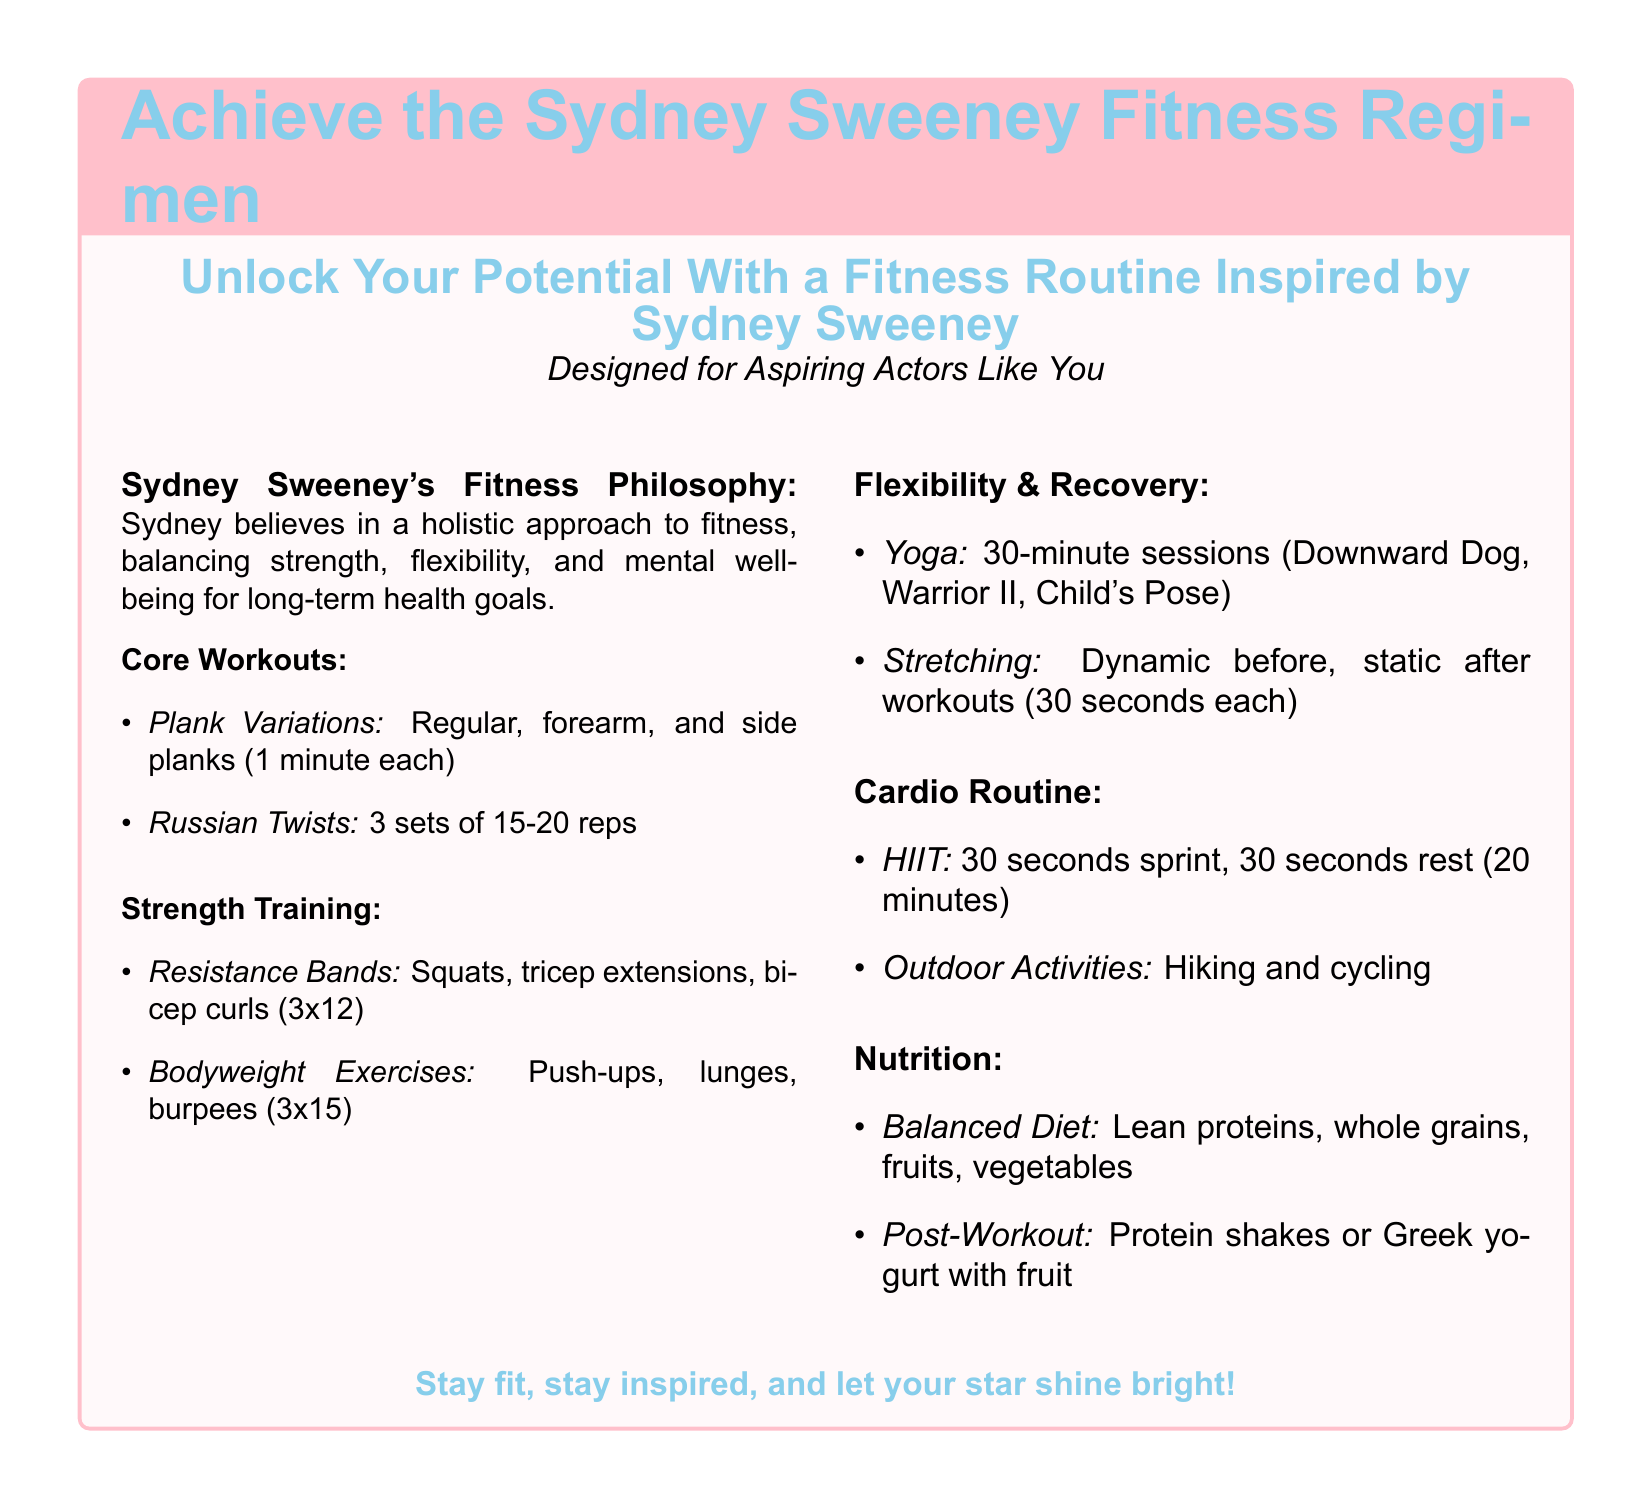What is Sydney Sweeney's fitness philosophy? The document states that Sydney believes in a holistic approach to fitness, balancing strength, flexibility, and mental well-being for long-term health goals.
Answer: holistic approach How long are the yoga sessions that Sydney includes in her fitness regimen? According to the document, the yoga sessions last for 30 minutes.
Answer: 30 minutes What type of exercises does Sydney include for core workouts? The document lists plank variations and Russian twists as her core workouts.
Answer: plank variations and Russian twists How many sets of Russian twists does Sydney perform? The document indicates that she performs 3 sets of 15-20 reps of Russian twists.
Answer: 3 sets of 15-20 reps What is included in Sydney's post-workout nutrition? The document mentions that her post-workout nutrition includes protein shakes or Greek yogurt with fruit.
Answer: protein shakes or Greek yogurt with fruit What is the first exercise listed under strength training? The document lists resistance bands squats as the first exercise under strength training.
Answer: resistance bands squats How long does Sydney's HIIT cardio routine last? The document states that the HIIT cardio routine lasts for 20 minutes.
Answer: 20 minutes What type of diet does Sydney follow according to the document? The document describes her diet as balanced, which includes lean proteins, whole grains, fruits, and vegetables.
Answer: balanced diet 